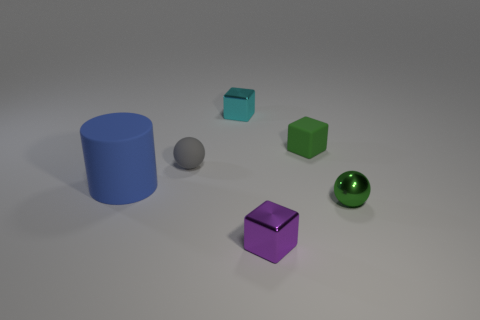Is there any other thing that is the same size as the cylinder?
Make the answer very short. No. What is the material of the purple object that is the same size as the green metallic ball?
Your answer should be very brief. Metal. Are there any tiny purple shiny objects on the right side of the tiny cyan shiny block?
Your answer should be compact. Yes. Are there an equal number of large blue cylinders that are to the right of the tiny metallic ball and large brown matte spheres?
Your answer should be compact. Yes. The green matte thing that is the same size as the cyan metal cube is what shape?
Your response must be concise. Cube. What is the material of the purple thing?
Offer a very short reply. Metal. What is the color of the cube that is behind the green metallic thing and left of the matte block?
Your response must be concise. Cyan. Is the number of tiny green metal objects behind the shiny ball the same as the number of small balls right of the small rubber block?
Keep it short and to the point. No. There is a tiny ball that is made of the same material as the blue cylinder; what is its color?
Provide a succinct answer. Gray. Is the color of the shiny sphere the same as the rubber object that is behind the gray matte object?
Your answer should be very brief. Yes. 